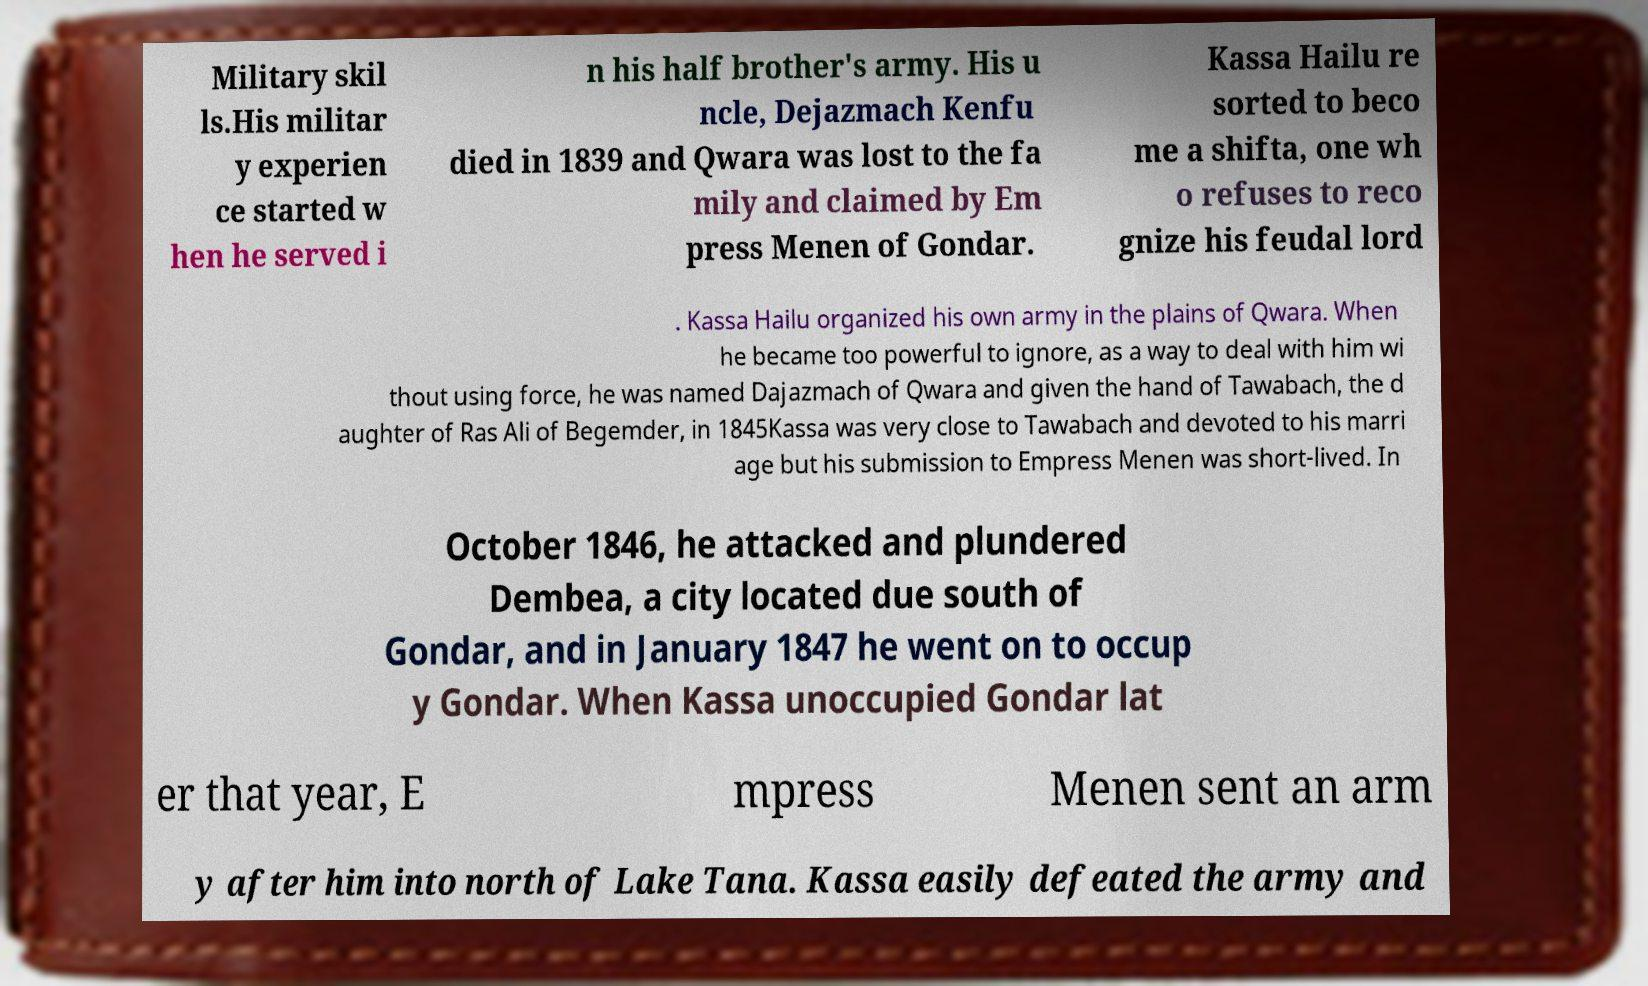Please read and relay the text visible in this image. What does it say? Military skil ls.His militar y experien ce started w hen he served i n his half brother's army. His u ncle, Dejazmach Kenfu died in 1839 and Qwara was lost to the fa mily and claimed by Em press Menen of Gondar. Kassa Hailu re sorted to beco me a shifta, one wh o refuses to reco gnize his feudal lord . Kassa Hailu organized his own army in the plains of Qwara. When he became too powerful to ignore, as a way to deal with him wi thout using force, he was named Dajazmach of Qwara and given the hand of Tawabach, the d aughter of Ras Ali of Begemder, in 1845Kassa was very close to Tawabach and devoted to his marri age but his submission to Empress Menen was short-lived. In October 1846, he attacked and plundered Dembea, a city located due south of Gondar, and in January 1847 he went on to occup y Gondar. When Kassa unoccupied Gondar lat er that year, E mpress Menen sent an arm y after him into north of Lake Tana. Kassa easily defeated the army and 